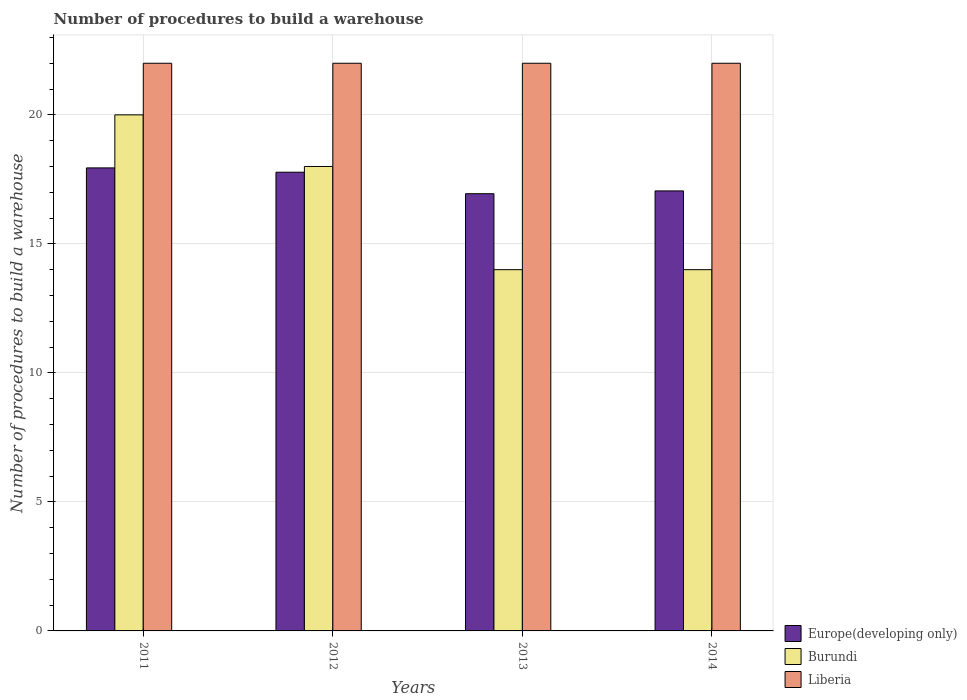Are the number of bars per tick equal to the number of legend labels?
Your answer should be compact. Yes. How many bars are there on the 1st tick from the left?
Provide a short and direct response. 3. What is the label of the 1st group of bars from the left?
Your answer should be very brief. 2011. Across all years, what is the maximum number of procedures to build a warehouse in in Europe(developing only)?
Offer a terse response. 17.94. Across all years, what is the minimum number of procedures to build a warehouse in in Liberia?
Give a very brief answer. 22. What is the total number of procedures to build a warehouse in in Europe(developing only) in the graph?
Your answer should be compact. 69.72. What is the difference between the number of procedures to build a warehouse in in Liberia in 2012 and that in 2014?
Offer a very short reply. 0. What is the difference between the number of procedures to build a warehouse in in Burundi in 2014 and the number of procedures to build a warehouse in in Europe(developing only) in 2013?
Offer a very short reply. -2.94. What is the average number of procedures to build a warehouse in in Burundi per year?
Provide a short and direct response. 16.5. In the year 2012, what is the difference between the number of procedures to build a warehouse in in Burundi and number of procedures to build a warehouse in in Europe(developing only)?
Offer a terse response. 0.22. What is the ratio of the number of procedures to build a warehouse in in Europe(developing only) in 2011 to that in 2012?
Offer a very short reply. 1.01. Is the number of procedures to build a warehouse in in Liberia in 2011 less than that in 2014?
Your response must be concise. No. Is the difference between the number of procedures to build a warehouse in in Burundi in 2011 and 2014 greater than the difference between the number of procedures to build a warehouse in in Europe(developing only) in 2011 and 2014?
Ensure brevity in your answer.  Yes. What is the difference between the highest and the second highest number of procedures to build a warehouse in in Liberia?
Provide a short and direct response. 0. In how many years, is the number of procedures to build a warehouse in in Liberia greater than the average number of procedures to build a warehouse in in Liberia taken over all years?
Ensure brevity in your answer.  0. Is the sum of the number of procedures to build a warehouse in in Burundi in 2012 and 2013 greater than the maximum number of procedures to build a warehouse in in Europe(developing only) across all years?
Provide a short and direct response. Yes. What does the 3rd bar from the left in 2013 represents?
Provide a short and direct response. Liberia. What does the 2nd bar from the right in 2014 represents?
Keep it short and to the point. Burundi. How many bars are there?
Offer a very short reply. 12. Are all the bars in the graph horizontal?
Your response must be concise. No. Are the values on the major ticks of Y-axis written in scientific E-notation?
Your answer should be very brief. No. Does the graph contain any zero values?
Give a very brief answer. No. Does the graph contain grids?
Provide a succinct answer. Yes. How many legend labels are there?
Your response must be concise. 3. How are the legend labels stacked?
Offer a very short reply. Vertical. What is the title of the graph?
Provide a short and direct response. Number of procedures to build a warehouse. What is the label or title of the Y-axis?
Ensure brevity in your answer.  Number of procedures to build a warehouse. What is the Number of procedures to build a warehouse in Europe(developing only) in 2011?
Offer a very short reply. 17.94. What is the Number of procedures to build a warehouse of Liberia in 2011?
Make the answer very short. 22. What is the Number of procedures to build a warehouse of Europe(developing only) in 2012?
Provide a short and direct response. 17.78. What is the Number of procedures to build a warehouse in Burundi in 2012?
Your answer should be very brief. 18. What is the Number of procedures to build a warehouse in Liberia in 2012?
Offer a very short reply. 22. What is the Number of procedures to build a warehouse in Europe(developing only) in 2013?
Offer a very short reply. 16.94. What is the Number of procedures to build a warehouse of Europe(developing only) in 2014?
Provide a short and direct response. 17.05. What is the Number of procedures to build a warehouse of Burundi in 2014?
Offer a terse response. 14. What is the Number of procedures to build a warehouse in Liberia in 2014?
Offer a very short reply. 22. Across all years, what is the maximum Number of procedures to build a warehouse of Europe(developing only)?
Offer a terse response. 17.94. Across all years, what is the maximum Number of procedures to build a warehouse in Burundi?
Offer a very short reply. 20. Across all years, what is the minimum Number of procedures to build a warehouse of Europe(developing only)?
Provide a short and direct response. 16.94. What is the total Number of procedures to build a warehouse in Europe(developing only) in the graph?
Ensure brevity in your answer.  69.72. What is the total Number of procedures to build a warehouse in Burundi in the graph?
Provide a succinct answer. 66. What is the difference between the Number of procedures to build a warehouse of Europe(developing only) in 2011 and that in 2012?
Offer a very short reply. 0.17. What is the difference between the Number of procedures to build a warehouse in Burundi in 2011 and that in 2013?
Ensure brevity in your answer.  6. What is the difference between the Number of procedures to build a warehouse in Liberia in 2011 and that in 2013?
Offer a terse response. 0. What is the difference between the Number of procedures to build a warehouse of Europe(developing only) in 2011 and that in 2014?
Your response must be concise. 0.89. What is the difference between the Number of procedures to build a warehouse in Burundi in 2012 and that in 2013?
Offer a terse response. 4. What is the difference between the Number of procedures to build a warehouse in Europe(developing only) in 2012 and that in 2014?
Provide a short and direct response. 0.73. What is the difference between the Number of procedures to build a warehouse in Burundi in 2012 and that in 2014?
Provide a short and direct response. 4. What is the difference between the Number of procedures to build a warehouse of Liberia in 2012 and that in 2014?
Keep it short and to the point. 0. What is the difference between the Number of procedures to build a warehouse in Europe(developing only) in 2013 and that in 2014?
Provide a succinct answer. -0.11. What is the difference between the Number of procedures to build a warehouse in Burundi in 2013 and that in 2014?
Your response must be concise. 0. What is the difference between the Number of procedures to build a warehouse in Liberia in 2013 and that in 2014?
Provide a short and direct response. 0. What is the difference between the Number of procedures to build a warehouse of Europe(developing only) in 2011 and the Number of procedures to build a warehouse of Burundi in 2012?
Your answer should be very brief. -0.06. What is the difference between the Number of procedures to build a warehouse of Europe(developing only) in 2011 and the Number of procedures to build a warehouse of Liberia in 2012?
Make the answer very short. -4.06. What is the difference between the Number of procedures to build a warehouse in Burundi in 2011 and the Number of procedures to build a warehouse in Liberia in 2012?
Offer a very short reply. -2. What is the difference between the Number of procedures to build a warehouse in Europe(developing only) in 2011 and the Number of procedures to build a warehouse in Burundi in 2013?
Provide a short and direct response. 3.94. What is the difference between the Number of procedures to build a warehouse of Europe(developing only) in 2011 and the Number of procedures to build a warehouse of Liberia in 2013?
Your answer should be compact. -4.06. What is the difference between the Number of procedures to build a warehouse of Burundi in 2011 and the Number of procedures to build a warehouse of Liberia in 2013?
Your response must be concise. -2. What is the difference between the Number of procedures to build a warehouse of Europe(developing only) in 2011 and the Number of procedures to build a warehouse of Burundi in 2014?
Keep it short and to the point. 3.94. What is the difference between the Number of procedures to build a warehouse in Europe(developing only) in 2011 and the Number of procedures to build a warehouse in Liberia in 2014?
Provide a short and direct response. -4.06. What is the difference between the Number of procedures to build a warehouse in Burundi in 2011 and the Number of procedures to build a warehouse in Liberia in 2014?
Provide a succinct answer. -2. What is the difference between the Number of procedures to build a warehouse of Europe(developing only) in 2012 and the Number of procedures to build a warehouse of Burundi in 2013?
Keep it short and to the point. 3.78. What is the difference between the Number of procedures to build a warehouse in Europe(developing only) in 2012 and the Number of procedures to build a warehouse in Liberia in 2013?
Your answer should be very brief. -4.22. What is the difference between the Number of procedures to build a warehouse in Burundi in 2012 and the Number of procedures to build a warehouse in Liberia in 2013?
Offer a terse response. -4. What is the difference between the Number of procedures to build a warehouse of Europe(developing only) in 2012 and the Number of procedures to build a warehouse of Burundi in 2014?
Provide a short and direct response. 3.78. What is the difference between the Number of procedures to build a warehouse of Europe(developing only) in 2012 and the Number of procedures to build a warehouse of Liberia in 2014?
Offer a terse response. -4.22. What is the difference between the Number of procedures to build a warehouse in Europe(developing only) in 2013 and the Number of procedures to build a warehouse in Burundi in 2014?
Give a very brief answer. 2.94. What is the difference between the Number of procedures to build a warehouse of Europe(developing only) in 2013 and the Number of procedures to build a warehouse of Liberia in 2014?
Your response must be concise. -5.06. What is the difference between the Number of procedures to build a warehouse of Burundi in 2013 and the Number of procedures to build a warehouse of Liberia in 2014?
Make the answer very short. -8. What is the average Number of procedures to build a warehouse in Europe(developing only) per year?
Provide a short and direct response. 17.43. What is the average Number of procedures to build a warehouse in Liberia per year?
Provide a short and direct response. 22. In the year 2011, what is the difference between the Number of procedures to build a warehouse in Europe(developing only) and Number of procedures to build a warehouse in Burundi?
Give a very brief answer. -2.06. In the year 2011, what is the difference between the Number of procedures to build a warehouse in Europe(developing only) and Number of procedures to build a warehouse in Liberia?
Offer a terse response. -4.06. In the year 2011, what is the difference between the Number of procedures to build a warehouse in Burundi and Number of procedures to build a warehouse in Liberia?
Offer a very short reply. -2. In the year 2012, what is the difference between the Number of procedures to build a warehouse in Europe(developing only) and Number of procedures to build a warehouse in Burundi?
Offer a very short reply. -0.22. In the year 2012, what is the difference between the Number of procedures to build a warehouse of Europe(developing only) and Number of procedures to build a warehouse of Liberia?
Offer a very short reply. -4.22. In the year 2013, what is the difference between the Number of procedures to build a warehouse of Europe(developing only) and Number of procedures to build a warehouse of Burundi?
Keep it short and to the point. 2.94. In the year 2013, what is the difference between the Number of procedures to build a warehouse of Europe(developing only) and Number of procedures to build a warehouse of Liberia?
Offer a terse response. -5.06. In the year 2013, what is the difference between the Number of procedures to build a warehouse of Burundi and Number of procedures to build a warehouse of Liberia?
Provide a short and direct response. -8. In the year 2014, what is the difference between the Number of procedures to build a warehouse in Europe(developing only) and Number of procedures to build a warehouse in Burundi?
Your response must be concise. 3.05. In the year 2014, what is the difference between the Number of procedures to build a warehouse of Europe(developing only) and Number of procedures to build a warehouse of Liberia?
Your answer should be very brief. -4.95. In the year 2014, what is the difference between the Number of procedures to build a warehouse of Burundi and Number of procedures to build a warehouse of Liberia?
Provide a succinct answer. -8. What is the ratio of the Number of procedures to build a warehouse in Europe(developing only) in 2011 to that in 2012?
Your response must be concise. 1.01. What is the ratio of the Number of procedures to build a warehouse of Burundi in 2011 to that in 2012?
Your answer should be very brief. 1.11. What is the ratio of the Number of procedures to build a warehouse in Europe(developing only) in 2011 to that in 2013?
Provide a short and direct response. 1.06. What is the ratio of the Number of procedures to build a warehouse of Burundi in 2011 to that in 2013?
Your answer should be very brief. 1.43. What is the ratio of the Number of procedures to build a warehouse of Europe(developing only) in 2011 to that in 2014?
Make the answer very short. 1.05. What is the ratio of the Number of procedures to build a warehouse in Burundi in 2011 to that in 2014?
Your answer should be compact. 1.43. What is the ratio of the Number of procedures to build a warehouse of Europe(developing only) in 2012 to that in 2013?
Your answer should be very brief. 1.05. What is the ratio of the Number of procedures to build a warehouse in Liberia in 2012 to that in 2013?
Your response must be concise. 1. What is the ratio of the Number of procedures to build a warehouse of Europe(developing only) in 2012 to that in 2014?
Your response must be concise. 1.04. What is the ratio of the Number of procedures to build a warehouse of Burundi in 2012 to that in 2014?
Offer a terse response. 1.29. What is the ratio of the Number of procedures to build a warehouse of Europe(developing only) in 2013 to that in 2014?
Offer a terse response. 0.99. What is the ratio of the Number of procedures to build a warehouse of Liberia in 2013 to that in 2014?
Offer a terse response. 1. What is the difference between the highest and the second highest Number of procedures to build a warehouse of Europe(developing only)?
Your response must be concise. 0.17. What is the difference between the highest and the second highest Number of procedures to build a warehouse in Burundi?
Provide a short and direct response. 2. What is the difference between the highest and the second highest Number of procedures to build a warehouse in Liberia?
Offer a terse response. 0. What is the difference between the highest and the lowest Number of procedures to build a warehouse in Europe(developing only)?
Make the answer very short. 1. What is the difference between the highest and the lowest Number of procedures to build a warehouse in Burundi?
Ensure brevity in your answer.  6. 